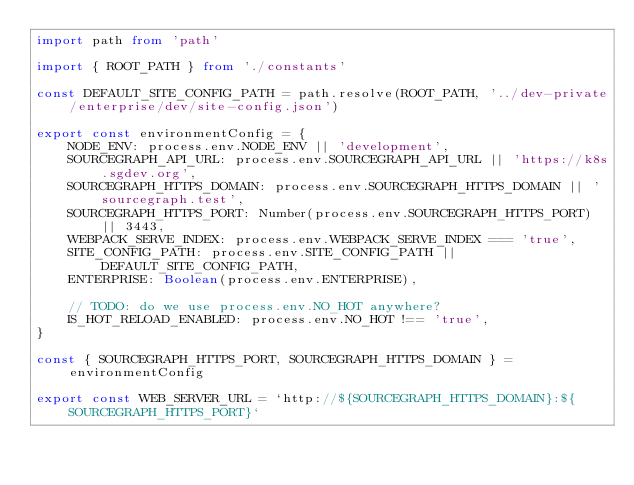Convert code to text. <code><loc_0><loc_0><loc_500><loc_500><_TypeScript_>import path from 'path'

import { ROOT_PATH } from './constants'

const DEFAULT_SITE_CONFIG_PATH = path.resolve(ROOT_PATH, '../dev-private/enterprise/dev/site-config.json')

export const environmentConfig = {
    NODE_ENV: process.env.NODE_ENV || 'development',
    SOURCEGRAPH_API_URL: process.env.SOURCEGRAPH_API_URL || 'https://k8s.sgdev.org',
    SOURCEGRAPH_HTTPS_DOMAIN: process.env.SOURCEGRAPH_HTTPS_DOMAIN || 'sourcegraph.test',
    SOURCEGRAPH_HTTPS_PORT: Number(process.env.SOURCEGRAPH_HTTPS_PORT) || 3443,
    WEBPACK_SERVE_INDEX: process.env.WEBPACK_SERVE_INDEX === 'true',
    SITE_CONFIG_PATH: process.env.SITE_CONFIG_PATH || DEFAULT_SITE_CONFIG_PATH,
    ENTERPRISE: Boolean(process.env.ENTERPRISE),

    // TODO: do we use process.env.NO_HOT anywhere?
    IS_HOT_RELOAD_ENABLED: process.env.NO_HOT !== 'true',
}

const { SOURCEGRAPH_HTTPS_PORT, SOURCEGRAPH_HTTPS_DOMAIN } = environmentConfig

export const WEB_SERVER_URL = `http://${SOURCEGRAPH_HTTPS_DOMAIN}:${SOURCEGRAPH_HTTPS_PORT}`
</code> 